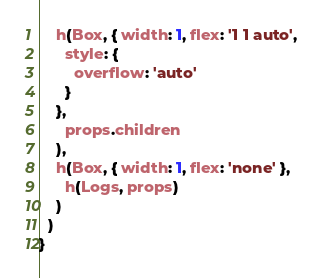Convert code to text. <code><loc_0><loc_0><loc_500><loc_500><_JavaScript_>    h(Box, { width: 1, flex: '1 1 auto',
      style: {
        overflow: 'auto'
      }
    },
      props.children
    ),
    h(Box, { width: 1, flex: 'none' },
      h(Logs, props)
    )
  )
}
</code> 